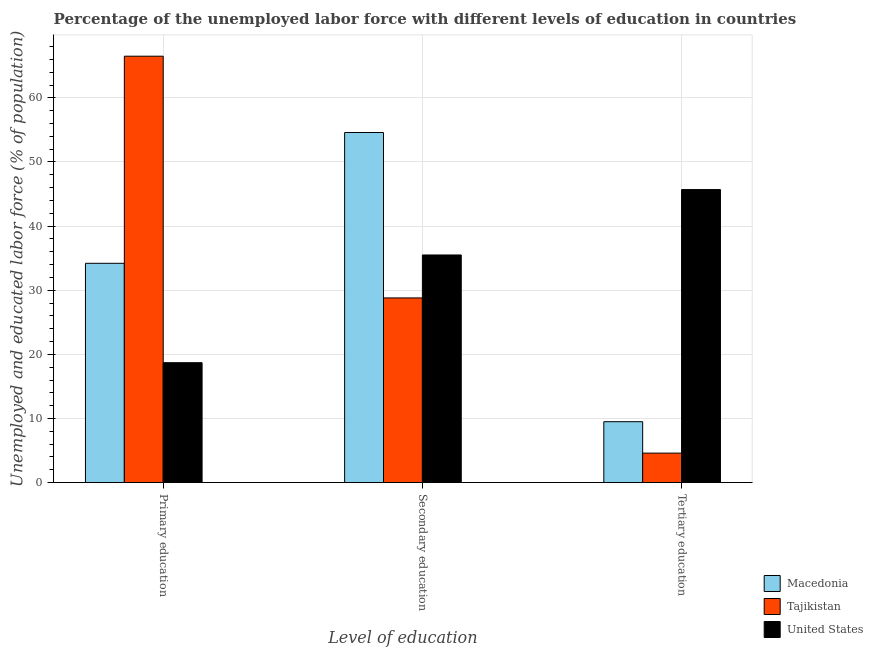How many groups of bars are there?
Provide a succinct answer. 3. Are the number of bars per tick equal to the number of legend labels?
Give a very brief answer. Yes. What is the label of the 2nd group of bars from the left?
Keep it short and to the point. Secondary education. What is the percentage of labor force who received secondary education in Tajikistan?
Offer a terse response. 28.8. Across all countries, what is the maximum percentage of labor force who received primary education?
Make the answer very short. 66.5. Across all countries, what is the minimum percentage of labor force who received secondary education?
Your answer should be very brief. 28.8. In which country was the percentage of labor force who received tertiary education minimum?
Offer a terse response. Tajikistan. What is the total percentage of labor force who received primary education in the graph?
Give a very brief answer. 119.4. What is the difference between the percentage of labor force who received secondary education in United States and that in Tajikistan?
Offer a very short reply. 6.7. What is the difference between the percentage of labor force who received tertiary education in Tajikistan and the percentage of labor force who received secondary education in United States?
Provide a short and direct response. -30.9. What is the average percentage of labor force who received tertiary education per country?
Your response must be concise. 19.93. What is the difference between the percentage of labor force who received primary education and percentage of labor force who received secondary education in United States?
Offer a terse response. -16.8. In how many countries, is the percentage of labor force who received tertiary education greater than 42 %?
Give a very brief answer. 1. What is the ratio of the percentage of labor force who received tertiary education in Tajikistan to that in United States?
Offer a terse response. 0.1. Is the difference between the percentage of labor force who received tertiary education in Macedonia and United States greater than the difference between the percentage of labor force who received primary education in Macedonia and United States?
Make the answer very short. No. What is the difference between the highest and the second highest percentage of labor force who received secondary education?
Your answer should be compact. 19.1. What is the difference between the highest and the lowest percentage of labor force who received primary education?
Offer a very short reply. 47.8. What does the 2nd bar from the left in Tertiary education represents?
Offer a very short reply. Tajikistan. Is it the case that in every country, the sum of the percentage of labor force who received primary education and percentage of labor force who received secondary education is greater than the percentage of labor force who received tertiary education?
Keep it short and to the point. Yes. How many bars are there?
Ensure brevity in your answer.  9. What is the title of the graph?
Offer a very short reply. Percentage of the unemployed labor force with different levels of education in countries. Does "Upper middle income" appear as one of the legend labels in the graph?
Make the answer very short. No. What is the label or title of the X-axis?
Provide a succinct answer. Level of education. What is the label or title of the Y-axis?
Offer a very short reply. Unemployed and educated labor force (% of population). What is the Unemployed and educated labor force (% of population) in Macedonia in Primary education?
Keep it short and to the point. 34.2. What is the Unemployed and educated labor force (% of population) in Tajikistan in Primary education?
Your answer should be compact. 66.5. What is the Unemployed and educated labor force (% of population) of United States in Primary education?
Your answer should be very brief. 18.7. What is the Unemployed and educated labor force (% of population) of Macedonia in Secondary education?
Your response must be concise. 54.6. What is the Unemployed and educated labor force (% of population) in Tajikistan in Secondary education?
Give a very brief answer. 28.8. What is the Unemployed and educated labor force (% of population) of United States in Secondary education?
Offer a very short reply. 35.5. What is the Unemployed and educated labor force (% of population) in Macedonia in Tertiary education?
Offer a very short reply. 9.5. What is the Unemployed and educated labor force (% of population) in Tajikistan in Tertiary education?
Give a very brief answer. 4.6. What is the Unemployed and educated labor force (% of population) in United States in Tertiary education?
Ensure brevity in your answer.  45.7. Across all Level of education, what is the maximum Unemployed and educated labor force (% of population) of Macedonia?
Ensure brevity in your answer.  54.6. Across all Level of education, what is the maximum Unemployed and educated labor force (% of population) of Tajikistan?
Provide a succinct answer. 66.5. Across all Level of education, what is the maximum Unemployed and educated labor force (% of population) in United States?
Ensure brevity in your answer.  45.7. Across all Level of education, what is the minimum Unemployed and educated labor force (% of population) in Tajikistan?
Give a very brief answer. 4.6. Across all Level of education, what is the minimum Unemployed and educated labor force (% of population) of United States?
Keep it short and to the point. 18.7. What is the total Unemployed and educated labor force (% of population) of Macedonia in the graph?
Your answer should be very brief. 98.3. What is the total Unemployed and educated labor force (% of population) in Tajikistan in the graph?
Provide a succinct answer. 99.9. What is the total Unemployed and educated labor force (% of population) in United States in the graph?
Provide a succinct answer. 99.9. What is the difference between the Unemployed and educated labor force (% of population) of Macedonia in Primary education and that in Secondary education?
Offer a terse response. -20.4. What is the difference between the Unemployed and educated labor force (% of population) of Tajikistan in Primary education and that in Secondary education?
Ensure brevity in your answer.  37.7. What is the difference between the Unemployed and educated labor force (% of population) of United States in Primary education and that in Secondary education?
Keep it short and to the point. -16.8. What is the difference between the Unemployed and educated labor force (% of population) of Macedonia in Primary education and that in Tertiary education?
Offer a terse response. 24.7. What is the difference between the Unemployed and educated labor force (% of population) in Tajikistan in Primary education and that in Tertiary education?
Give a very brief answer. 61.9. What is the difference between the Unemployed and educated labor force (% of population) of Macedonia in Secondary education and that in Tertiary education?
Your answer should be compact. 45.1. What is the difference between the Unemployed and educated labor force (% of population) of Tajikistan in Secondary education and that in Tertiary education?
Keep it short and to the point. 24.2. What is the difference between the Unemployed and educated labor force (% of population) in Tajikistan in Primary education and the Unemployed and educated labor force (% of population) in United States in Secondary education?
Offer a very short reply. 31. What is the difference between the Unemployed and educated labor force (% of population) in Macedonia in Primary education and the Unemployed and educated labor force (% of population) in Tajikistan in Tertiary education?
Offer a very short reply. 29.6. What is the difference between the Unemployed and educated labor force (% of population) in Macedonia in Primary education and the Unemployed and educated labor force (% of population) in United States in Tertiary education?
Give a very brief answer. -11.5. What is the difference between the Unemployed and educated labor force (% of population) in Tajikistan in Primary education and the Unemployed and educated labor force (% of population) in United States in Tertiary education?
Provide a short and direct response. 20.8. What is the difference between the Unemployed and educated labor force (% of population) of Macedonia in Secondary education and the Unemployed and educated labor force (% of population) of Tajikistan in Tertiary education?
Your answer should be compact. 50. What is the difference between the Unemployed and educated labor force (% of population) in Macedonia in Secondary education and the Unemployed and educated labor force (% of population) in United States in Tertiary education?
Provide a succinct answer. 8.9. What is the difference between the Unemployed and educated labor force (% of population) of Tajikistan in Secondary education and the Unemployed and educated labor force (% of population) of United States in Tertiary education?
Offer a very short reply. -16.9. What is the average Unemployed and educated labor force (% of population) of Macedonia per Level of education?
Your response must be concise. 32.77. What is the average Unemployed and educated labor force (% of population) in Tajikistan per Level of education?
Provide a short and direct response. 33.3. What is the average Unemployed and educated labor force (% of population) in United States per Level of education?
Provide a succinct answer. 33.3. What is the difference between the Unemployed and educated labor force (% of population) in Macedonia and Unemployed and educated labor force (% of population) in Tajikistan in Primary education?
Offer a terse response. -32.3. What is the difference between the Unemployed and educated labor force (% of population) in Tajikistan and Unemployed and educated labor force (% of population) in United States in Primary education?
Offer a terse response. 47.8. What is the difference between the Unemployed and educated labor force (% of population) in Macedonia and Unemployed and educated labor force (% of population) in Tajikistan in Secondary education?
Provide a short and direct response. 25.8. What is the difference between the Unemployed and educated labor force (% of population) of Tajikistan and Unemployed and educated labor force (% of population) of United States in Secondary education?
Your response must be concise. -6.7. What is the difference between the Unemployed and educated labor force (% of population) of Macedonia and Unemployed and educated labor force (% of population) of United States in Tertiary education?
Keep it short and to the point. -36.2. What is the difference between the Unemployed and educated labor force (% of population) of Tajikistan and Unemployed and educated labor force (% of population) of United States in Tertiary education?
Your answer should be compact. -41.1. What is the ratio of the Unemployed and educated labor force (% of population) of Macedonia in Primary education to that in Secondary education?
Give a very brief answer. 0.63. What is the ratio of the Unemployed and educated labor force (% of population) in Tajikistan in Primary education to that in Secondary education?
Provide a succinct answer. 2.31. What is the ratio of the Unemployed and educated labor force (% of population) of United States in Primary education to that in Secondary education?
Your answer should be compact. 0.53. What is the ratio of the Unemployed and educated labor force (% of population) of Macedonia in Primary education to that in Tertiary education?
Ensure brevity in your answer.  3.6. What is the ratio of the Unemployed and educated labor force (% of population) in Tajikistan in Primary education to that in Tertiary education?
Give a very brief answer. 14.46. What is the ratio of the Unemployed and educated labor force (% of population) in United States in Primary education to that in Tertiary education?
Make the answer very short. 0.41. What is the ratio of the Unemployed and educated labor force (% of population) of Macedonia in Secondary education to that in Tertiary education?
Keep it short and to the point. 5.75. What is the ratio of the Unemployed and educated labor force (% of population) in Tajikistan in Secondary education to that in Tertiary education?
Your answer should be very brief. 6.26. What is the ratio of the Unemployed and educated labor force (% of population) of United States in Secondary education to that in Tertiary education?
Offer a terse response. 0.78. What is the difference between the highest and the second highest Unemployed and educated labor force (% of population) in Macedonia?
Offer a very short reply. 20.4. What is the difference between the highest and the second highest Unemployed and educated labor force (% of population) of Tajikistan?
Offer a terse response. 37.7. What is the difference between the highest and the second highest Unemployed and educated labor force (% of population) of United States?
Your answer should be compact. 10.2. What is the difference between the highest and the lowest Unemployed and educated labor force (% of population) of Macedonia?
Keep it short and to the point. 45.1. What is the difference between the highest and the lowest Unemployed and educated labor force (% of population) of Tajikistan?
Keep it short and to the point. 61.9. 